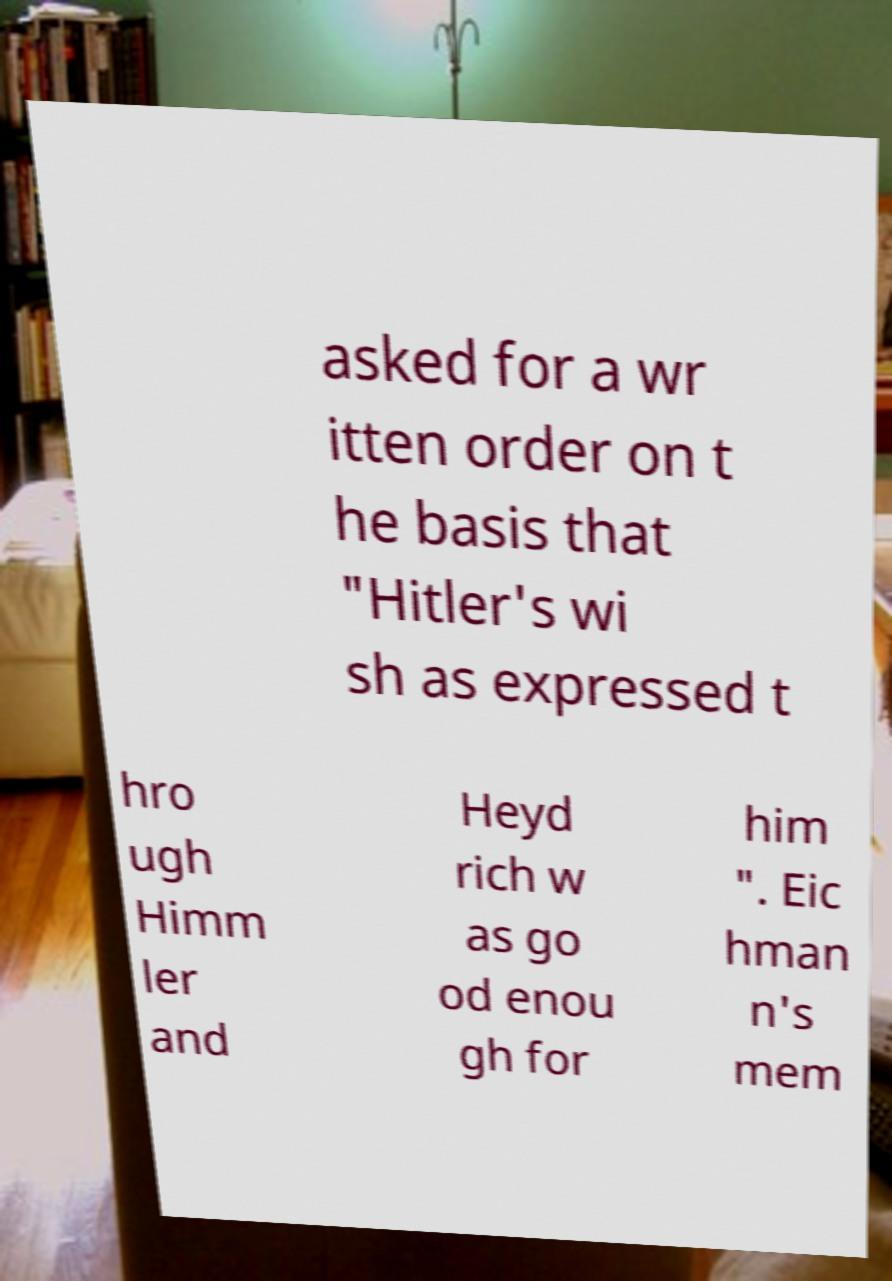I need the written content from this picture converted into text. Can you do that? asked for a wr itten order on t he basis that "Hitler's wi sh as expressed t hro ugh Himm ler and Heyd rich w as go od enou gh for him ". Eic hman n's mem 